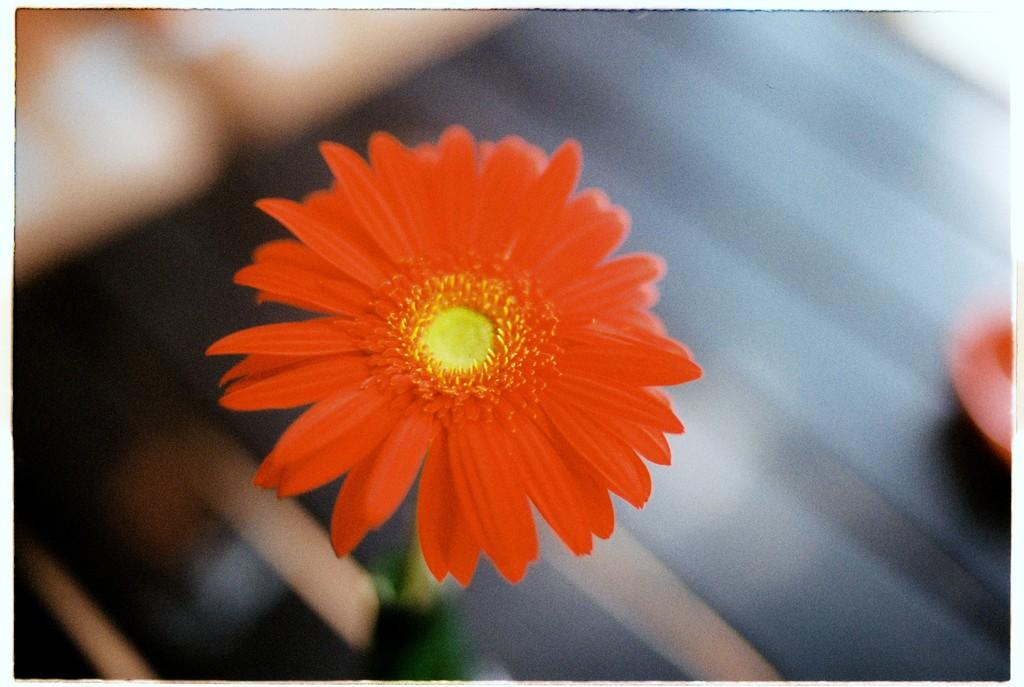What is the main subject of the image? There is a flower in the image. Can you describe the background of the image? The background of the image is blurred. What type of trousers is the flower wearing in the image? There are no trousers present in the image, as the flower is not a person or wearing any clothing items. 